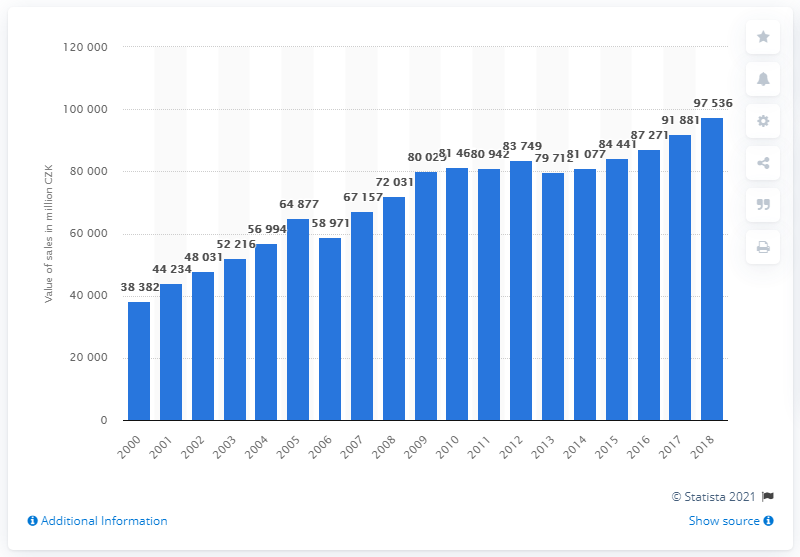Identify some key points in this picture. In 2018, the value of pharmaceutical sales in Czechia was 97,536. 